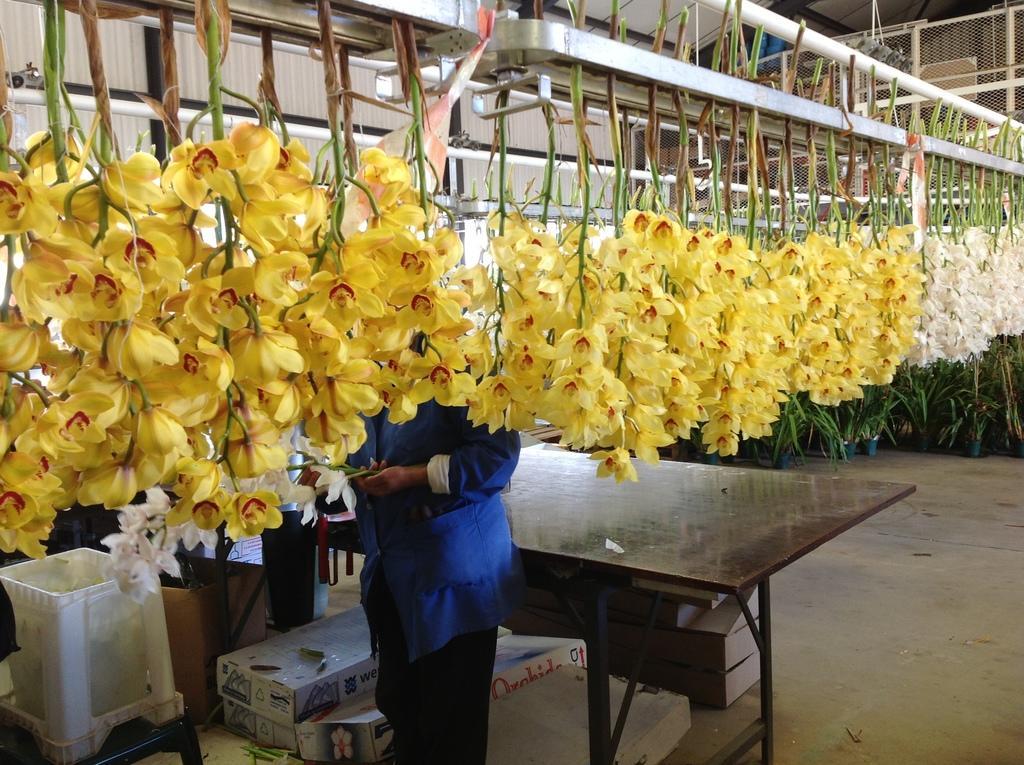Describe this image in one or two sentences. In this image I can see flowers and a person is standing. 